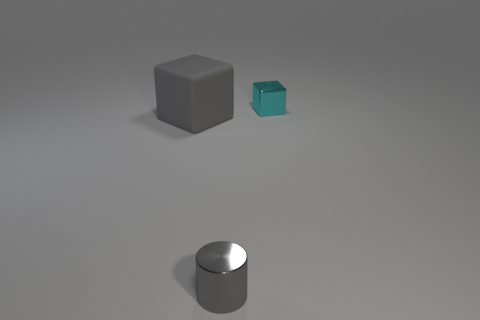Add 2 cyan blocks. How many objects exist? 5 Subtract all cylinders. How many objects are left? 2 Subtract 1 cylinders. How many cylinders are left? 0 Add 2 cylinders. How many cylinders are left? 3 Add 1 big gray spheres. How many big gray spheres exist? 1 Subtract 0 brown cylinders. How many objects are left? 3 Subtract all green cubes. Subtract all yellow cylinders. How many cubes are left? 2 Subtract all gray spheres. How many cyan blocks are left? 1 Subtract all yellow matte cylinders. Subtract all cubes. How many objects are left? 1 